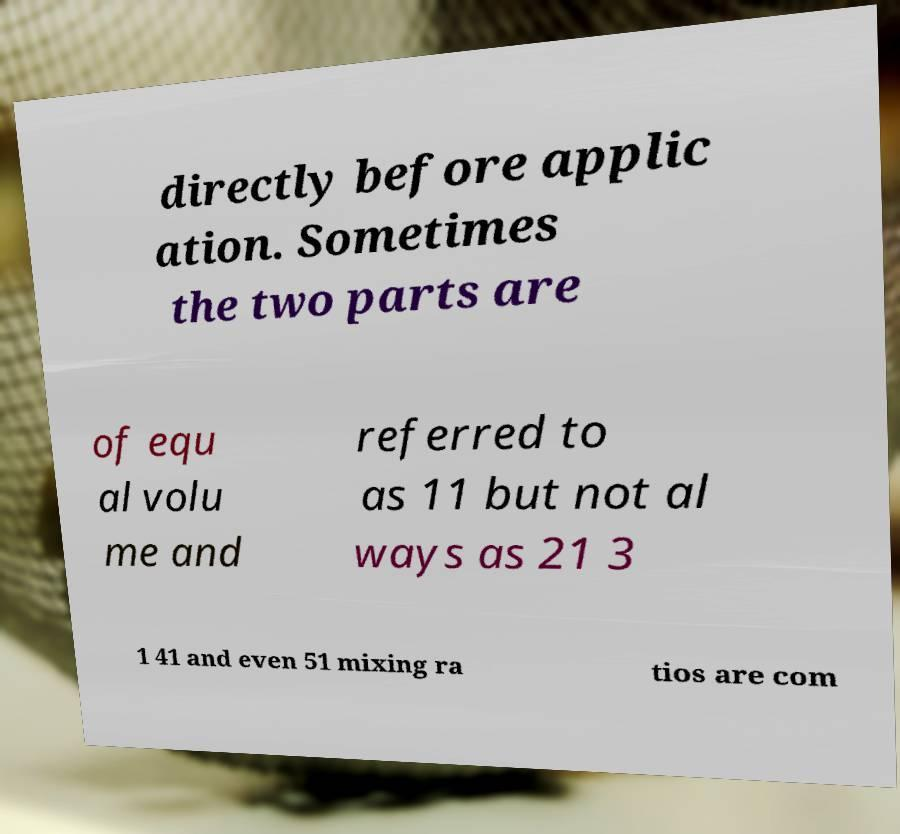Can you accurately transcribe the text from the provided image for me? directly before applic ation. Sometimes the two parts are of equ al volu me and referred to as 11 but not al ways as 21 3 1 41 and even 51 mixing ra tios are com 